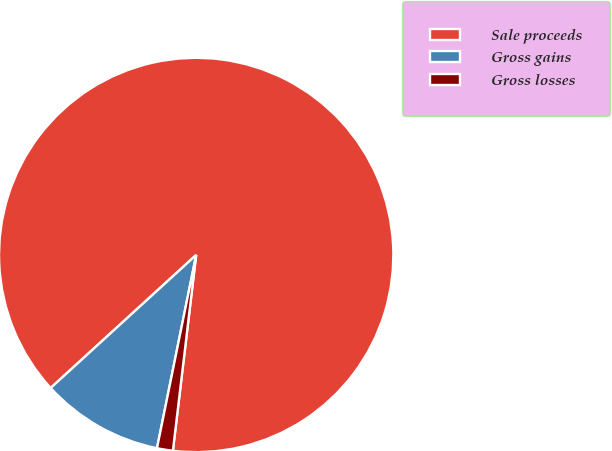Convert chart. <chart><loc_0><loc_0><loc_500><loc_500><pie_chart><fcel>Sale proceeds<fcel>Gross gains<fcel>Gross losses<nl><fcel>88.67%<fcel>10.03%<fcel>1.3%<nl></chart> 